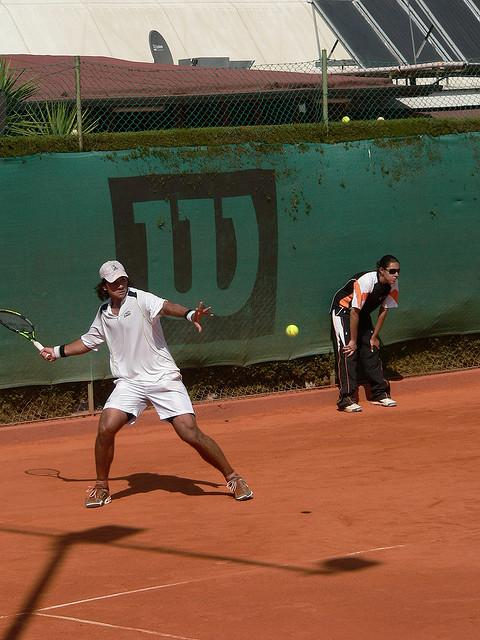What company is sponsoring the tennis match? Please explain your reasoning. wilson. The logo of the company, a lowercase letter w, is visible on the tarp covering the court's fence. 